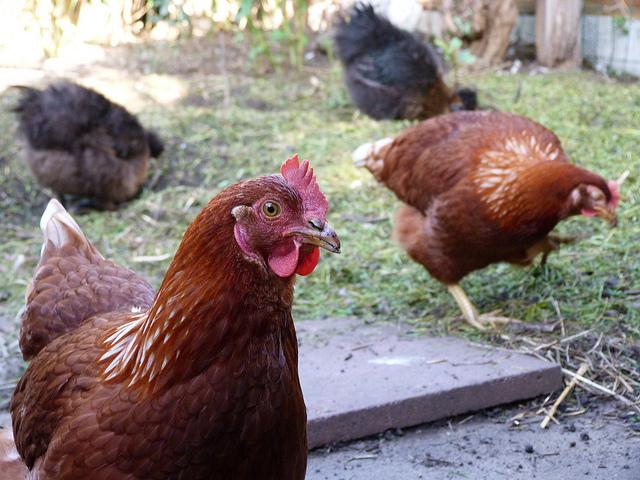How many chickens?
Give a very brief answer. 4. Are all these animals the same color?
Concise answer only. No. Is the chicken looking at the camera?
Concise answer only. Yes. 